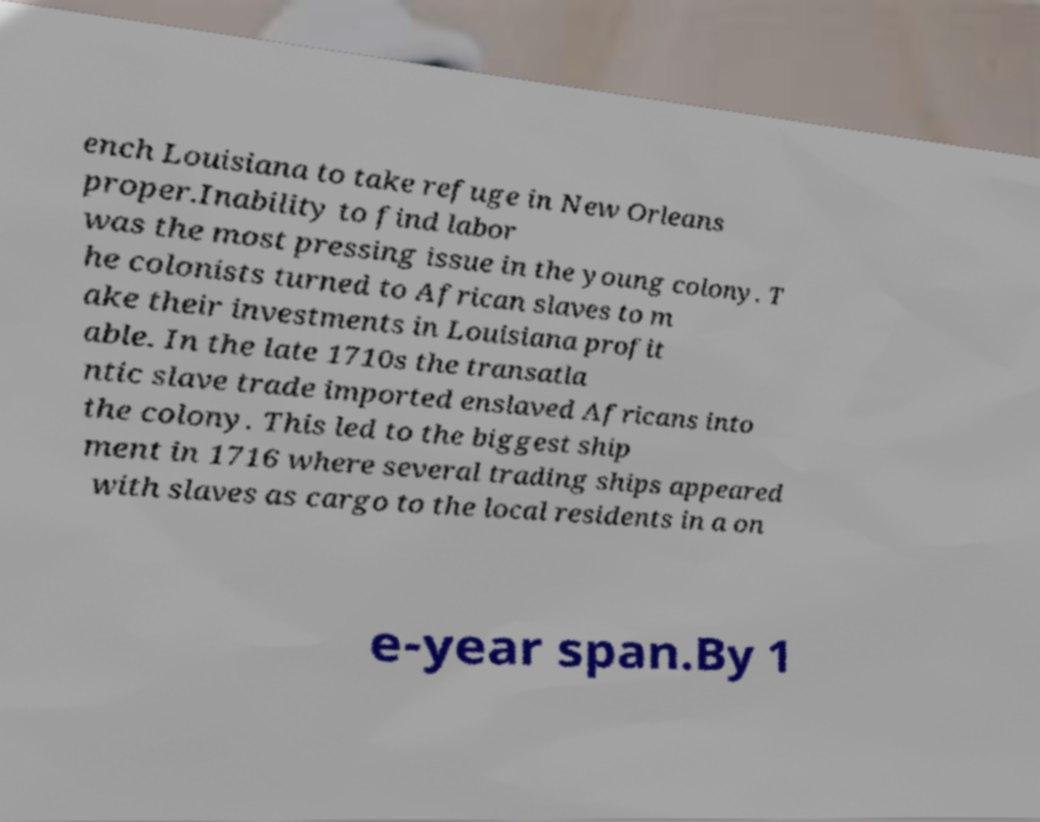There's text embedded in this image that I need extracted. Can you transcribe it verbatim? ench Louisiana to take refuge in New Orleans proper.Inability to find labor was the most pressing issue in the young colony. T he colonists turned to African slaves to m ake their investments in Louisiana profit able. In the late 1710s the transatla ntic slave trade imported enslaved Africans into the colony. This led to the biggest ship ment in 1716 where several trading ships appeared with slaves as cargo to the local residents in a on e-year span.By 1 